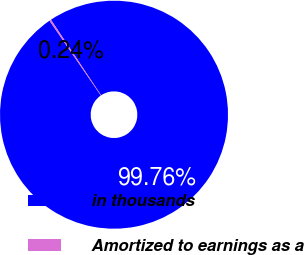Convert chart to OTSL. <chart><loc_0><loc_0><loc_500><loc_500><pie_chart><fcel>in thousands<fcel>Amortized to earnings as a<nl><fcel>99.76%<fcel>0.24%<nl></chart> 